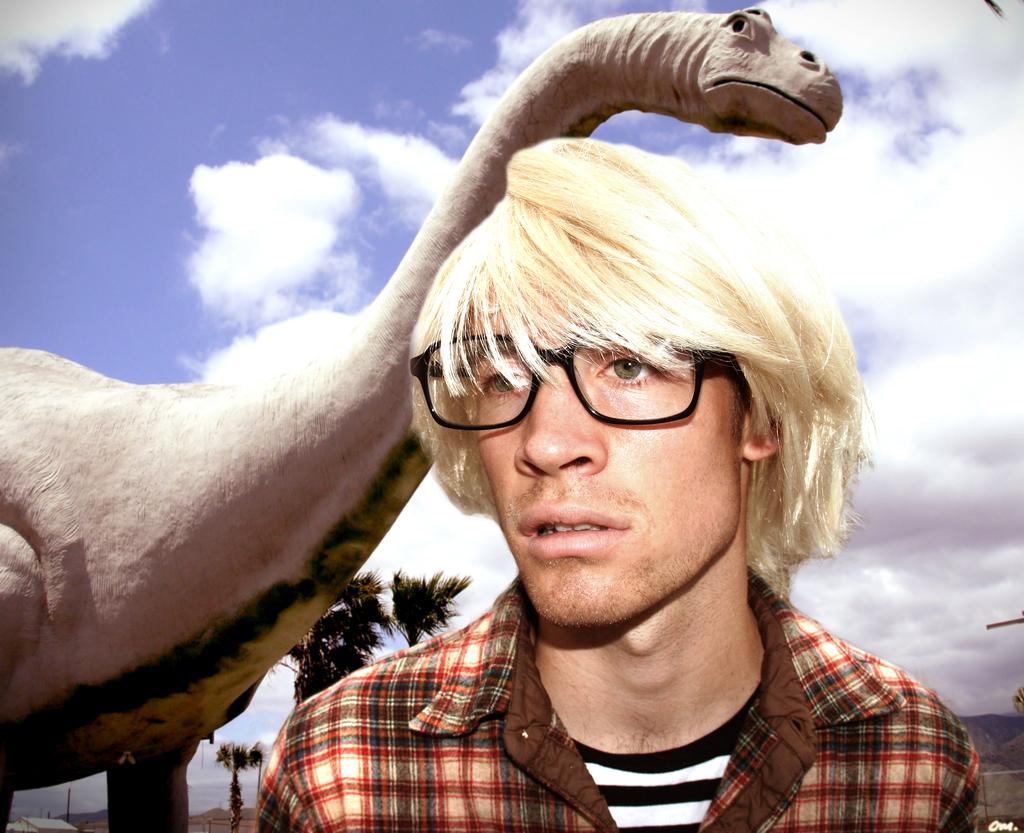Who is present in the image? There is a man in the image. What is the man wearing? The man is wearing spectacles. What other object can be seen in the image? There is a dinosaur in the image. What type of natural environment is visible in the image? There are trees in the image. How would you describe the sky in the image? The sky is blue and cloudy. What type of steam is coming out of the dinosaur's mouth in the image? There is no steam coming out of the dinosaur's mouth in the image, as the dinosaur is not a living creature and does not have the ability to produce steam. 